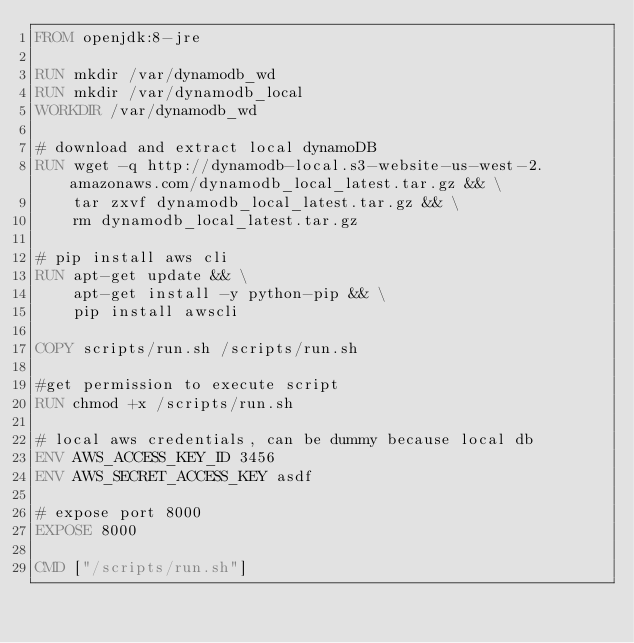Convert code to text. <code><loc_0><loc_0><loc_500><loc_500><_Dockerfile_>FROM openjdk:8-jre

RUN mkdir /var/dynamodb_wd
RUN mkdir /var/dynamodb_local
WORKDIR /var/dynamodb_wd

# download and extract local dynamoDB
RUN wget -q http://dynamodb-local.s3-website-us-west-2.amazonaws.com/dynamodb_local_latest.tar.gz && \
    tar zxvf dynamodb_local_latest.tar.gz && \
    rm dynamodb_local_latest.tar.gz

# pip install aws cli
RUN apt-get update && \
    apt-get install -y python-pip && \
    pip install awscli

COPY scripts/run.sh /scripts/run.sh

#get permission to execute script
RUN chmod +x /scripts/run.sh

# local aws credentials, can be dummy because local db
ENV AWS_ACCESS_KEY_ID 3456
ENV AWS_SECRET_ACCESS_KEY asdf

# expose port 8000
EXPOSE 8000

CMD ["/scripts/run.sh"]
</code> 